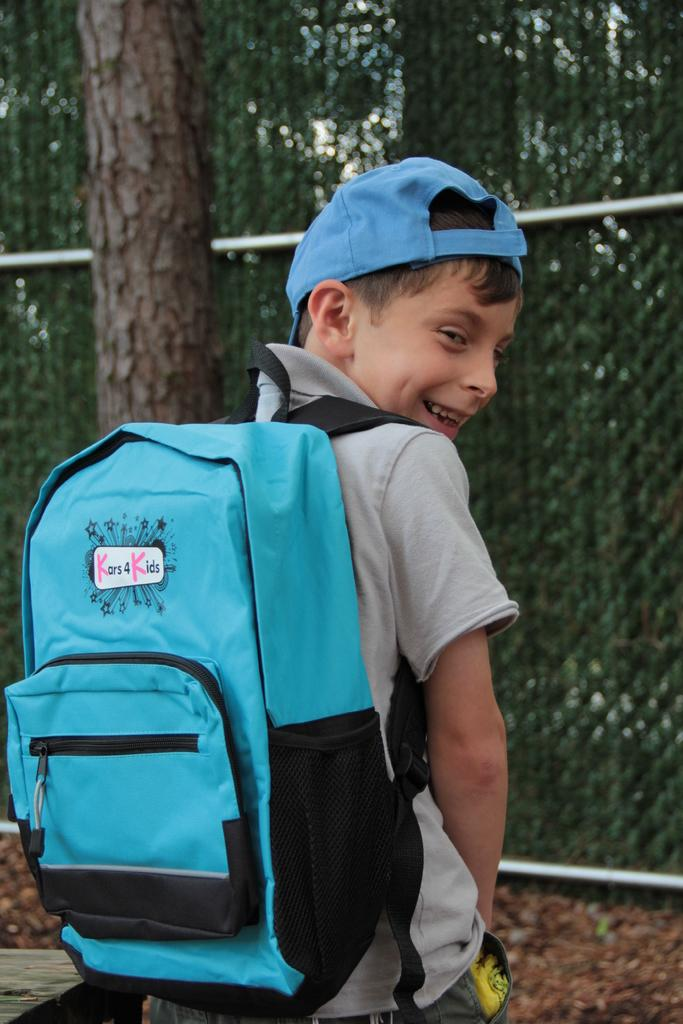Provide a one-sentence caption for the provided image. A kid is wearing a blue Kars 4 Kids backpack and smiles looking back,. 